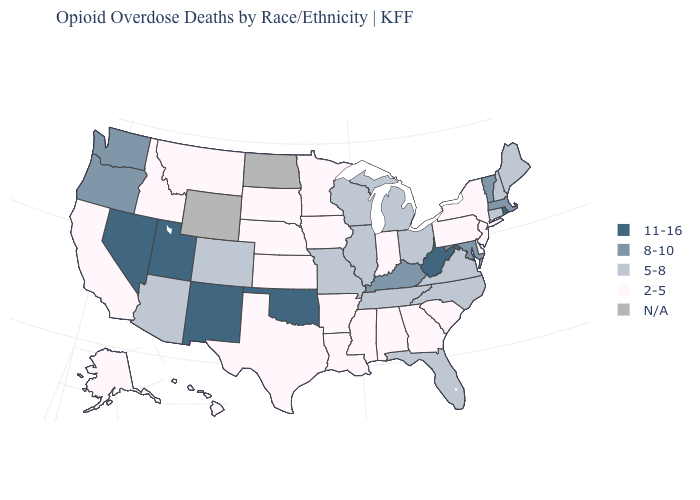Name the states that have a value in the range 2-5?
Be succinct. Alabama, Alaska, Arkansas, California, Delaware, Georgia, Hawaii, Idaho, Indiana, Iowa, Kansas, Louisiana, Minnesota, Mississippi, Montana, Nebraska, New Jersey, New York, Pennsylvania, South Carolina, South Dakota, Texas. What is the value of South Carolina?
Give a very brief answer. 2-5. Which states have the lowest value in the South?
Give a very brief answer. Alabama, Arkansas, Delaware, Georgia, Louisiana, Mississippi, South Carolina, Texas. Among the states that border California , which have the lowest value?
Be succinct. Arizona. Does South Carolina have the highest value in the South?
Short answer required. No. Name the states that have a value in the range 8-10?
Keep it brief. Kentucky, Maryland, Massachusetts, Oregon, Vermont, Washington. Among the states that border Wisconsin , which have the lowest value?
Quick response, please. Iowa, Minnesota. Among the states that border Idaho , which have the lowest value?
Give a very brief answer. Montana. Does Rhode Island have the highest value in the Northeast?
Give a very brief answer. Yes. Name the states that have a value in the range 11-16?
Concise answer only. Nevada, New Mexico, Oklahoma, Rhode Island, Utah, West Virginia. What is the lowest value in states that border North Dakota?
Concise answer only. 2-5. What is the value of Arizona?
Short answer required. 5-8. Does the first symbol in the legend represent the smallest category?
Answer briefly. No. What is the value of Michigan?
Write a very short answer. 5-8. What is the lowest value in the West?
Short answer required. 2-5. 